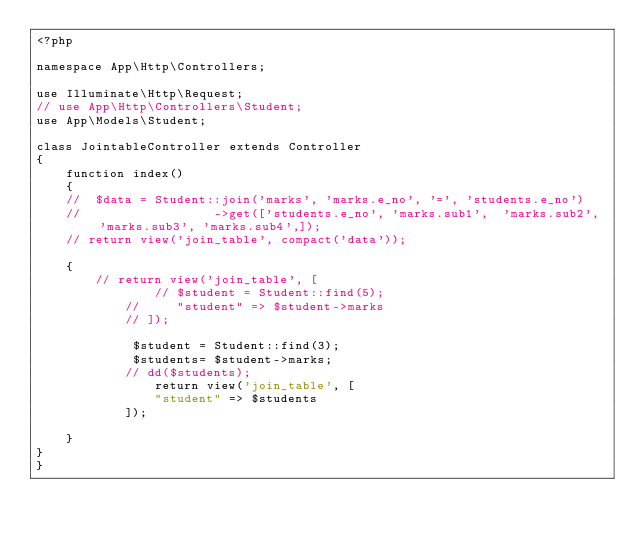<code> <loc_0><loc_0><loc_500><loc_500><_PHP_><?php

namespace App\Http\Controllers;

use Illuminate\Http\Request;
// use App\Http\Controllers\Student;
use App\Models\Student;

class JointableController extends Controller
{
    function index()
    {
    // 	$data = Student::join('marks', 'marks.e_no', '=', 'students.e_no')
    //           		->get(['students.e_no', 'marks.sub1',  'marks.sub2', 'marks.sub3', 'marks.sub4',]);
    // return view('join_table', compact('data'));
       
    {
        // return view('join_table', [
                // $student = Student::find(5);
            //     "student" => $student->marks
            // ]);

             $student = Student::find(3);
             $students= $student->marks;
            // dd($students);
                return view('join_table', [
                "student" => $students
            ]);
           
    }
}
}
</code> 